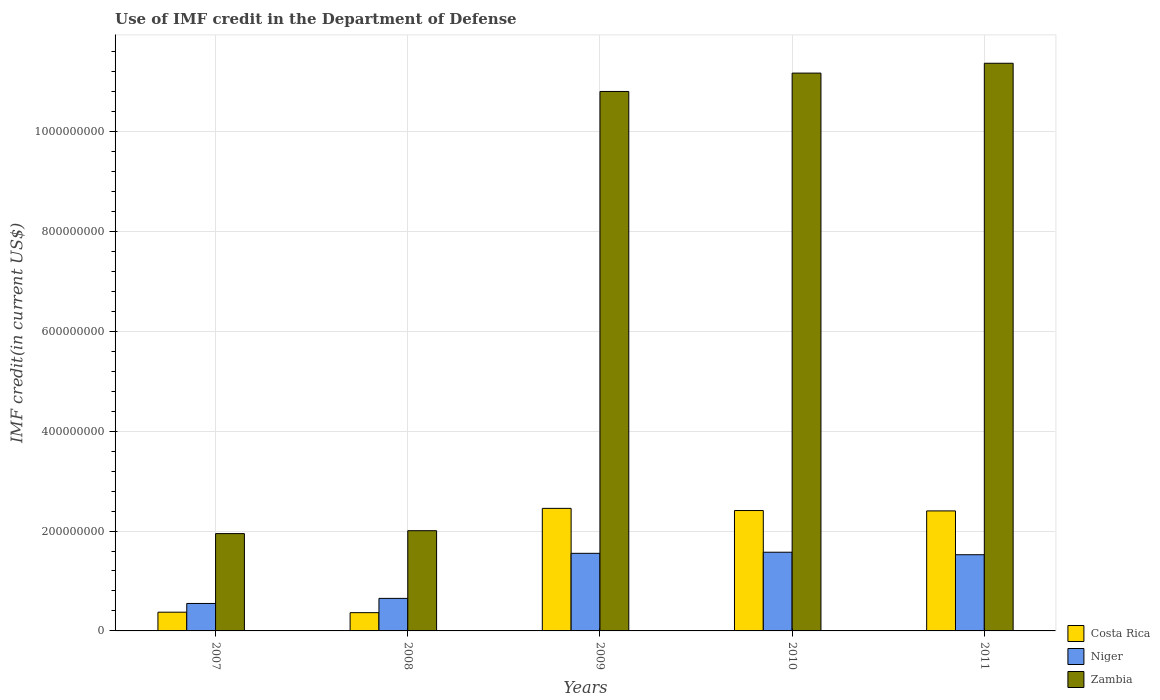How many different coloured bars are there?
Keep it short and to the point. 3. What is the label of the 5th group of bars from the left?
Offer a very short reply. 2011. What is the IMF credit in the Department of Defense in Costa Rica in 2007?
Offer a very short reply. 3.75e+07. Across all years, what is the maximum IMF credit in the Department of Defense in Niger?
Ensure brevity in your answer.  1.58e+08. Across all years, what is the minimum IMF credit in the Department of Defense in Niger?
Your response must be concise. 5.50e+07. In which year was the IMF credit in the Department of Defense in Niger maximum?
Keep it short and to the point. 2010. In which year was the IMF credit in the Department of Defense in Zambia minimum?
Give a very brief answer. 2007. What is the total IMF credit in the Department of Defense in Niger in the graph?
Your answer should be compact. 5.86e+08. What is the difference between the IMF credit in the Department of Defense in Zambia in 2009 and that in 2010?
Provide a short and direct response. -3.68e+07. What is the difference between the IMF credit in the Department of Defense in Costa Rica in 2007 and the IMF credit in the Department of Defense in Niger in 2009?
Make the answer very short. -1.18e+08. What is the average IMF credit in the Department of Defense in Costa Rica per year?
Your response must be concise. 1.60e+08. In the year 2007, what is the difference between the IMF credit in the Department of Defense in Niger and IMF credit in the Department of Defense in Costa Rica?
Your answer should be compact. 1.75e+07. In how many years, is the IMF credit in the Department of Defense in Niger greater than 1040000000 US$?
Make the answer very short. 0. What is the ratio of the IMF credit in the Department of Defense in Costa Rica in 2009 to that in 2011?
Offer a terse response. 1.02. Is the difference between the IMF credit in the Department of Defense in Niger in 2010 and 2011 greater than the difference between the IMF credit in the Department of Defense in Costa Rica in 2010 and 2011?
Offer a terse response. Yes. What is the difference between the highest and the second highest IMF credit in the Department of Defense in Zambia?
Your response must be concise. 1.97e+07. What is the difference between the highest and the lowest IMF credit in the Department of Defense in Niger?
Offer a very short reply. 1.03e+08. In how many years, is the IMF credit in the Department of Defense in Niger greater than the average IMF credit in the Department of Defense in Niger taken over all years?
Offer a very short reply. 3. Is the sum of the IMF credit in the Department of Defense in Costa Rica in 2009 and 2010 greater than the maximum IMF credit in the Department of Defense in Niger across all years?
Provide a succinct answer. Yes. What does the 2nd bar from the left in 2010 represents?
Your answer should be compact. Niger. What does the 2nd bar from the right in 2009 represents?
Make the answer very short. Niger. Is it the case that in every year, the sum of the IMF credit in the Department of Defense in Costa Rica and IMF credit in the Department of Defense in Niger is greater than the IMF credit in the Department of Defense in Zambia?
Your response must be concise. No. How many bars are there?
Keep it short and to the point. 15. How many years are there in the graph?
Your response must be concise. 5. Does the graph contain grids?
Give a very brief answer. Yes. Where does the legend appear in the graph?
Your response must be concise. Bottom right. How are the legend labels stacked?
Your answer should be very brief. Vertical. What is the title of the graph?
Your answer should be very brief. Use of IMF credit in the Department of Defense. Does "St. Kitts and Nevis" appear as one of the legend labels in the graph?
Your response must be concise. No. What is the label or title of the X-axis?
Offer a terse response. Years. What is the label or title of the Y-axis?
Give a very brief answer. IMF credit(in current US$). What is the IMF credit(in current US$) of Costa Rica in 2007?
Provide a succinct answer. 3.75e+07. What is the IMF credit(in current US$) in Niger in 2007?
Your answer should be very brief. 5.50e+07. What is the IMF credit(in current US$) in Zambia in 2007?
Provide a short and direct response. 1.95e+08. What is the IMF credit(in current US$) in Costa Rica in 2008?
Give a very brief answer. 3.65e+07. What is the IMF credit(in current US$) in Niger in 2008?
Keep it short and to the point. 6.52e+07. What is the IMF credit(in current US$) of Zambia in 2008?
Provide a succinct answer. 2.01e+08. What is the IMF credit(in current US$) of Costa Rica in 2009?
Ensure brevity in your answer.  2.45e+08. What is the IMF credit(in current US$) of Niger in 2009?
Offer a very short reply. 1.55e+08. What is the IMF credit(in current US$) of Zambia in 2009?
Your answer should be compact. 1.08e+09. What is the IMF credit(in current US$) in Costa Rica in 2010?
Offer a terse response. 2.41e+08. What is the IMF credit(in current US$) in Niger in 2010?
Keep it short and to the point. 1.58e+08. What is the IMF credit(in current US$) of Zambia in 2010?
Ensure brevity in your answer.  1.12e+09. What is the IMF credit(in current US$) of Costa Rica in 2011?
Your answer should be very brief. 2.40e+08. What is the IMF credit(in current US$) of Niger in 2011?
Provide a short and direct response. 1.53e+08. What is the IMF credit(in current US$) in Zambia in 2011?
Your response must be concise. 1.14e+09. Across all years, what is the maximum IMF credit(in current US$) of Costa Rica?
Give a very brief answer. 2.45e+08. Across all years, what is the maximum IMF credit(in current US$) of Niger?
Your answer should be very brief. 1.58e+08. Across all years, what is the maximum IMF credit(in current US$) in Zambia?
Make the answer very short. 1.14e+09. Across all years, what is the minimum IMF credit(in current US$) in Costa Rica?
Provide a succinct answer. 3.65e+07. Across all years, what is the minimum IMF credit(in current US$) in Niger?
Your answer should be compact. 5.50e+07. Across all years, what is the minimum IMF credit(in current US$) of Zambia?
Provide a succinct answer. 1.95e+08. What is the total IMF credit(in current US$) in Costa Rica in the graph?
Provide a succinct answer. 8.01e+08. What is the total IMF credit(in current US$) of Niger in the graph?
Your answer should be very brief. 5.86e+08. What is the total IMF credit(in current US$) of Zambia in the graph?
Provide a succinct answer. 3.73e+09. What is the difference between the IMF credit(in current US$) in Costa Rica in 2007 and that in 2008?
Your response must be concise. 9.49e+05. What is the difference between the IMF credit(in current US$) of Niger in 2007 and that in 2008?
Make the answer very short. -1.02e+07. What is the difference between the IMF credit(in current US$) of Zambia in 2007 and that in 2008?
Provide a short and direct response. -5.83e+06. What is the difference between the IMF credit(in current US$) in Costa Rica in 2007 and that in 2009?
Give a very brief answer. -2.08e+08. What is the difference between the IMF credit(in current US$) in Niger in 2007 and that in 2009?
Provide a succinct answer. -1.00e+08. What is the difference between the IMF credit(in current US$) of Zambia in 2007 and that in 2009?
Make the answer very short. -8.85e+08. What is the difference between the IMF credit(in current US$) in Costa Rica in 2007 and that in 2010?
Offer a very short reply. -2.04e+08. What is the difference between the IMF credit(in current US$) of Niger in 2007 and that in 2010?
Provide a short and direct response. -1.03e+08. What is the difference between the IMF credit(in current US$) in Zambia in 2007 and that in 2010?
Keep it short and to the point. -9.22e+08. What is the difference between the IMF credit(in current US$) of Costa Rica in 2007 and that in 2011?
Your answer should be very brief. -2.03e+08. What is the difference between the IMF credit(in current US$) of Niger in 2007 and that in 2011?
Provide a succinct answer. -9.76e+07. What is the difference between the IMF credit(in current US$) in Zambia in 2007 and that in 2011?
Your response must be concise. -9.42e+08. What is the difference between the IMF credit(in current US$) in Costa Rica in 2008 and that in 2009?
Ensure brevity in your answer.  -2.09e+08. What is the difference between the IMF credit(in current US$) of Niger in 2008 and that in 2009?
Offer a terse response. -9.02e+07. What is the difference between the IMF credit(in current US$) of Zambia in 2008 and that in 2009?
Your answer should be very brief. -8.80e+08. What is the difference between the IMF credit(in current US$) of Costa Rica in 2008 and that in 2010?
Offer a terse response. -2.05e+08. What is the difference between the IMF credit(in current US$) in Niger in 2008 and that in 2010?
Your answer should be compact. -9.24e+07. What is the difference between the IMF credit(in current US$) in Zambia in 2008 and that in 2010?
Your answer should be very brief. -9.16e+08. What is the difference between the IMF credit(in current US$) of Costa Rica in 2008 and that in 2011?
Ensure brevity in your answer.  -2.04e+08. What is the difference between the IMF credit(in current US$) of Niger in 2008 and that in 2011?
Give a very brief answer. -8.74e+07. What is the difference between the IMF credit(in current US$) in Zambia in 2008 and that in 2011?
Give a very brief answer. -9.36e+08. What is the difference between the IMF credit(in current US$) in Costa Rica in 2009 and that in 2010?
Make the answer very short. 4.33e+06. What is the difference between the IMF credit(in current US$) of Niger in 2009 and that in 2010?
Your answer should be compact. -2.18e+06. What is the difference between the IMF credit(in current US$) in Zambia in 2009 and that in 2010?
Provide a short and direct response. -3.68e+07. What is the difference between the IMF credit(in current US$) in Costa Rica in 2009 and that in 2011?
Provide a short and direct response. 5.08e+06. What is the difference between the IMF credit(in current US$) of Niger in 2009 and that in 2011?
Your answer should be very brief. 2.82e+06. What is the difference between the IMF credit(in current US$) of Zambia in 2009 and that in 2011?
Provide a short and direct response. -5.65e+07. What is the difference between the IMF credit(in current US$) of Costa Rica in 2010 and that in 2011?
Provide a short and direct response. 7.45e+05. What is the difference between the IMF credit(in current US$) of Niger in 2010 and that in 2011?
Provide a short and direct response. 5.00e+06. What is the difference between the IMF credit(in current US$) of Zambia in 2010 and that in 2011?
Provide a succinct answer. -1.97e+07. What is the difference between the IMF credit(in current US$) in Costa Rica in 2007 and the IMF credit(in current US$) in Niger in 2008?
Offer a terse response. -2.77e+07. What is the difference between the IMF credit(in current US$) in Costa Rica in 2007 and the IMF credit(in current US$) in Zambia in 2008?
Ensure brevity in your answer.  -1.63e+08. What is the difference between the IMF credit(in current US$) of Niger in 2007 and the IMF credit(in current US$) of Zambia in 2008?
Your answer should be compact. -1.46e+08. What is the difference between the IMF credit(in current US$) in Costa Rica in 2007 and the IMF credit(in current US$) in Niger in 2009?
Ensure brevity in your answer.  -1.18e+08. What is the difference between the IMF credit(in current US$) in Costa Rica in 2007 and the IMF credit(in current US$) in Zambia in 2009?
Give a very brief answer. -1.04e+09. What is the difference between the IMF credit(in current US$) in Niger in 2007 and the IMF credit(in current US$) in Zambia in 2009?
Your answer should be compact. -1.03e+09. What is the difference between the IMF credit(in current US$) of Costa Rica in 2007 and the IMF credit(in current US$) of Niger in 2010?
Your answer should be compact. -1.20e+08. What is the difference between the IMF credit(in current US$) in Costa Rica in 2007 and the IMF credit(in current US$) in Zambia in 2010?
Ensure brevity in your answer.  -1.08e+09. What is the difference between the IMF credit(in current US$) in Niger in 2007 and the IMF credit(in current US$) in Zambia in 2010?
Your answer should be compact. -1.06e+09. What is the difference between the IMF credit(in current US$) in Costa Rica in 2007 and the IMF credit(in current US$) in Niger in 2011?
Ensure brevity in your answer.  -1.15e+08. What is the difference between the IMF credit(in current US$) in Costa Rica in 2007 and the IMF credit(in current US$) in Zambia in 2011?
Ensure brevity in your answer.  -1.10e+09. What is the difference between the IMF credit(in current US$) of Niger in 2007 and the IMF credit(in current US$) of Zambia in 2011?
Ensure brevity in your answer.  -1.08e+09. What is the difference between the IMF credit(in current US$) in Costa Rica in 2008 and the IMF credit(in current US$) in Niger in 2009?
Offer a terse response. -1.19e+08. What is the difference between the IMF credit(in current US$) in Costa Rica in 2008 and the IMF credit(in current US$) in Zambia in 2009?
Make the answer very short. -1.04e+09. What is the difference between the IMF credit(in current US$) of Niger in 2008 and the IMF credit(in current US$) of Zambia in 2009?
Keep it short and to the point. -1.02e+09. What is the difference between the IMF credit(in current US$) of Costa Rica in 2008 and the IMF credit(in current US$) of Niger in 2010?
Offer a terse response. -1.21e+08. What is the difference between the IMF credit(in current US$) in Costa Rica in 2008 and the IMF credit(in current US$) in Zambia in 2010?
Provide a short and direct response. -1.08e+09. What is the difference between the IMF credit(in current US$) of Niger in 2008 and the IMF credit(in current US$) of Zambia in 2010?
Your answer should be very brief. -1.05e+09. What is the difference between the IMF credit(in current US$) in Costa Rica in 2008 and the IMF credit(in current US$) in Niger in 2011?
Keep it short and to the point. -1.16e+08. What is the difference between the IMF credit(in current US$) in Costa Rica in 2008 and the IMF credit(in current US$) in Zambia in 2011?
Offer a very short reply. -1.10e+09. What is the difference between the IMF credit(in current US$) of Niger in 2008 and the IMF credit(in current US$) of Zambia in 2011?
Provide a short and direct response. -1.07e+09. What is the difference between the IMF credit(in current US$) in Costa Rica in 2009 and the IMF credit(in current US$) in Niger in 2010?
Your response must be concise. 8.78e+07. What is the difference between the IMF credit(in current US$) in Costa Rica in 2009 and the IMF credit(in current US$) in Zambia in 2010?
Offer a very short reply. -8.72e+08. What is the difference between the IMF credit(in current US$) in Niger in 2009 and the IMF credit(in current US$) in Zambia in 2010?
Keep it short and to the point. -9.62e+08. What is the difference between the IMF credit(in current US$) of Costa Rica in 2009 and the IMF credit(in current US$) of Niger in 2011?
Provide a succinct answer. 9.28e+07. What is the difference between the IMF credit(in current US$) of Costa Rica in 2009 and the IMF credit(in current US$) of Zambia in 2011?
Keep it short and to the point. -8.91e+08. What is the difference between the IMF credit(in current US$) in Niger in 2009 and the IMF credit(in current US$) in Zambia in 2011?
Provide a short and direct response. -9.81e+08. What is the difference between the IMF credit(in current US$) in Costa Rica in 2010 and the IMF credit(in current US$) in Niger in 2011?
Your response must be concise. 8.85e+07. What is the difference between the IMF credit(in current US$) of Costa Rica in 2010 and the IMF credit(in current US$) of Zambia in 2011?
Your response must be concise. -8.96e+08. What is the difference between the IMF credit(in current US$) in Niger in 2010 and the IMF credit(in current US$) in Zambia in 2011?
Keep it short and to the point. -9.79e+08. What is the average IMF credit(in current US$) in Costa Rica per year?
Your answer should be compact. 1.60e+08. What is the average IMF credit(in current US$) of Niger per year?
Your response must be concise. 1.17e+08. What is the average IMF credit(in current US$) of Zambia per year?
Provide a short and direct response. 7.46e+08. In the year 2007, what is the difference between the IMF credit(in current US$) of Costa Rica and IMF credit(in current US$) of Niger?
Your response must be concise. -1.75e+07. In the year 2007, what is the difference between the IMF credit(in current US$) of Costa Rica and IMF credit(in current US$) of Zambia?
Your response must be concise. -1.57e+08. In the year 2007, what is the difference between the IMF credit(in current US$) of Niger and IMF credit(in current US$) of Zambia?
Keep it short and to the point. -1.40e+08. In the year 2008, what is the difference between the IMF credit(in current US$) of Costa Rica and IMF credit(in current US$) of Niger?
Your response must be concise. -2.86e+07. In the year 2008, what is the difference between the IMF credit(in current US$) of Costa Rica and IMF credit(in current US$) of Zambia?
Offer a terse response. -1.64e+08. In the year 2008, what is the difference between the IMF credit(in current US$) of Niger and IMF credit(in current US$) of Zambia?
Offer a terse response. -1.36e+08. In the year 2009, what is the difference between the IMF credit(in current US$) in Costa Rica and IMF credit(in current US$) in Niger?
Provide a short and direct response. 9.00e+07. In the year 2009, what is the difference between the IMF credit(in current US$) of Costa Rica and IMF credit(in current US$) of Zambia?
Make the answer very short. -8.35e+08. In the year 2009, what is the difference between the IMF credit(in current US$) in Niger and IMF credit(in current US$) in Zambia?
Your response must be concise. -9.25e+08. In the year 2010, what is the difference between the IMF credit(in current US$) in Costa Rica and IMF credit(in current US$) in Niger?
Your response must be concise. 8.35e+07. In the year 2010, what is the difference between the IMF credit(in current US$) in Costa Rica and IMF credit(in current US$) in Zambia?
Your answer should be compact. -8.76e+08. In the year 2010, what is the difference between the IMF credit(in current US$) in Niger and IMF credit(in current US$) in Zambia?
Make the answer very short. -9.59e+08. In the year 2011, what is the difference between the IMF credit(in current US$) in Costa Rica and IMF credit(in current US$) in Niger?
Offer a terse response. 8.77e+07. In the year 2011, what is the difference between the IMF credit(in current US$) in Costa Rica and IMF credit(in current US$) in Zambia?
Give a very brief answer. -8.96e+08. In the year 2011, what is the difference between the IMF credit(in current US$) of Niger and IMF credit(in current US$) of Zambia?
Give a very brief answer. -9.84e+08. What is the ratio of the IMF credit(in current US$) of Costa Rica in 2007 to that in 2008?
Make the answer very short. 1.03. What is the ratio of the IMF credit(in current US$) of Niger in 2007 to that in 2008?
Your answer should be compact. 0.84. What is the ratio of the IMF credit(in current US$) of Zambia in 2007 to that in 2008?
Your answer should be very brief. 0.97. What is the ratio of the IMF credit(in current US$) in Costa Rica in 2007 to that in 2009?
Your response must be concise. 0.15. What is the ratio of the IMF credit(in current US$) in Niger in 2007 to that in 2009?
Your answer should be compact. 0.35. What is the ratio of the IMF credit(in current US$) of Zambia in 2007 to that in 2009?
Your response must be concise. 0.18. What is the ratio of the IMF credit(in current US$) in Costa Rica in 2007 to that in 2010?
Offer a terse response. 0.16. What is the ratio of the IMF credit(in current US$) in Niger in 2007 to that in 2010?
Give a very brief answer. 0.35. What is the ratio of the IMF credit(in current US$) of Zambia in 2007 to that in 2010?
Make the answer very short. 0.17. What is the ratio of the IMF credit(in current US$) in Costa Rica in 2007 to that in 2011?
Ensure brevity in your answer.  0.16. What is the ratio of the IMF credit(in current US$) of Niger in 2007 to that in 2011?
Offer a terse response. 0.36. What is the ratio of the IMF credit(in current US$) of Zambia in 2007 to that in 2011?
Your answer should be compact. 0.17. What is the ratio of the IMF credit(in current US$) of Costa Rica in 2008 to that in 2009?
Offer a very short reply. 0.15. What is the ratio of the IMF credit(in current US$) of Niger in 2008 to that in 2009?
Offer a very short reply. 0.42. What is the ratio of the IMF credit(in current US$) of Zambia in 2008 to that in 2009?
Your answer should be compact. 0.19. What is the ratio of the IMF credit(in current US$) of Costa Rica in 2008 to that in 2010?
Offer a very short reply. 0.15. What is the ratio of the IMF credit(in current US$) in Niger in 2008 to that in 2010?
Make the answer very short. 0.41. What is the ratio of the IMF credit(in current US$) in Zambia in 2008 to that in 2010?
Provide a short and direct response. 0.18. What is the ratio of the IMF credit(in current US$) in Costa Rica in 2008 to that in 2011?
Your answer should be compact. 0.15. What is the ratio of the IMF credit(in current US$) in Niger in 2008 to that in 2011?
Give a very brief answer. 0.43. What is the ratio of the IMF credit(in current US$) of Zambia in 2008 to that in 2011?
Ensure brevity in your answer.  0.18. What is the ratio of the IMF credit(in current US$) of Costa Rica in 2009 to that in 2010?
Your answer should be very brief. 1.02. What is the ratio of the IMF credit(in current US$) in Niger in 2009 to that in 2010?
Make the answer very short. 0.99. What is the ratio of the IMF credit(in current US$) of Zambia in 2009 to that in 2010?
Keep it short and to the point. 0.97. What is the ratio of the IMF credit(in current US$) of Costa Rica in 2009 to that in 2011?
Keep it short and to the point. 1.02. What is the ratio of the IMF credit(in current US$) in Niger in 2009 to that in 2011?
Provide a short and direct response. 1.02. What is the ratio of the IMF credit(in current US$) in Zambia in 2009 to that in 2011?
Your response must be concise. 0.95. What is the ratio of the IMF credit(in current US$) in Niger in 2010 to that in 2011?
Your answer should be very brief. 1.03. What is the ratio of the IMF credit(in current US$) in Zambia in 2010 to that in 2011?
Your response must be concise. 0.98. What is the difference between the highest and the second highest IMF credit(in current US$) of Costa Rica?
Your answer should be compact. 4.33e+06. What is the difference between the highest and the second highest IMF credit(in current US$) of Niger?
Provide a short and direct response. 2.18e+06. What is the difference between the highest and the second highest IMF credit(in current US$) of Zambia?
Your answer should be very brief. 1.97e+07. What is the difference between the highest and the lowest IMF credit(in current US$) in Costa Rica?
Your answer should be compact. 2.09e+08. What is the difference between the highest and the lowest IMF credit(in current US$) of Niger?
Your answer should be very brief. 1.03e+08. What is the difference between the highest and the lowest IMF credit(in current US$) in Zambia?
Your answer should be compact. 9.42e+08. 